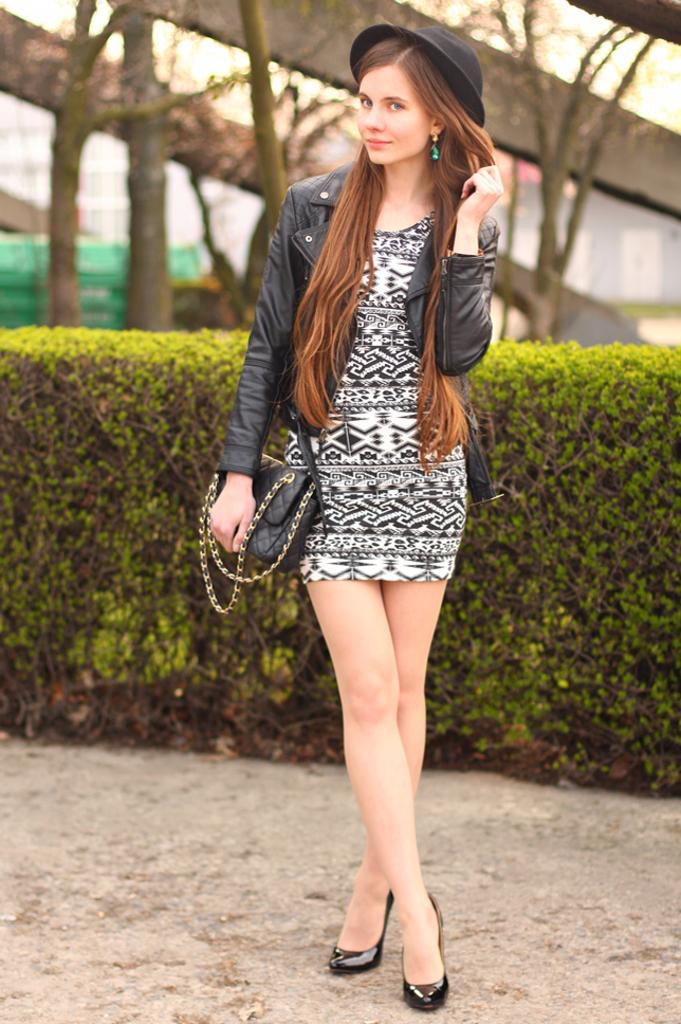What is the main subject of the image? There is a woman standing in the image. What is the woman's position in relation to the ground? The woman is standing on the ground. What type of vegetation can be seen in the background of the image? There are bushes and trees in the background of the image. What part of the natural environment is visible in the image? The sky is visible in the background of the image. What type of furniture is the woman using to make her discovery in the image? There is no furniture present in the image, nor is there any indication of a discovery being made. 